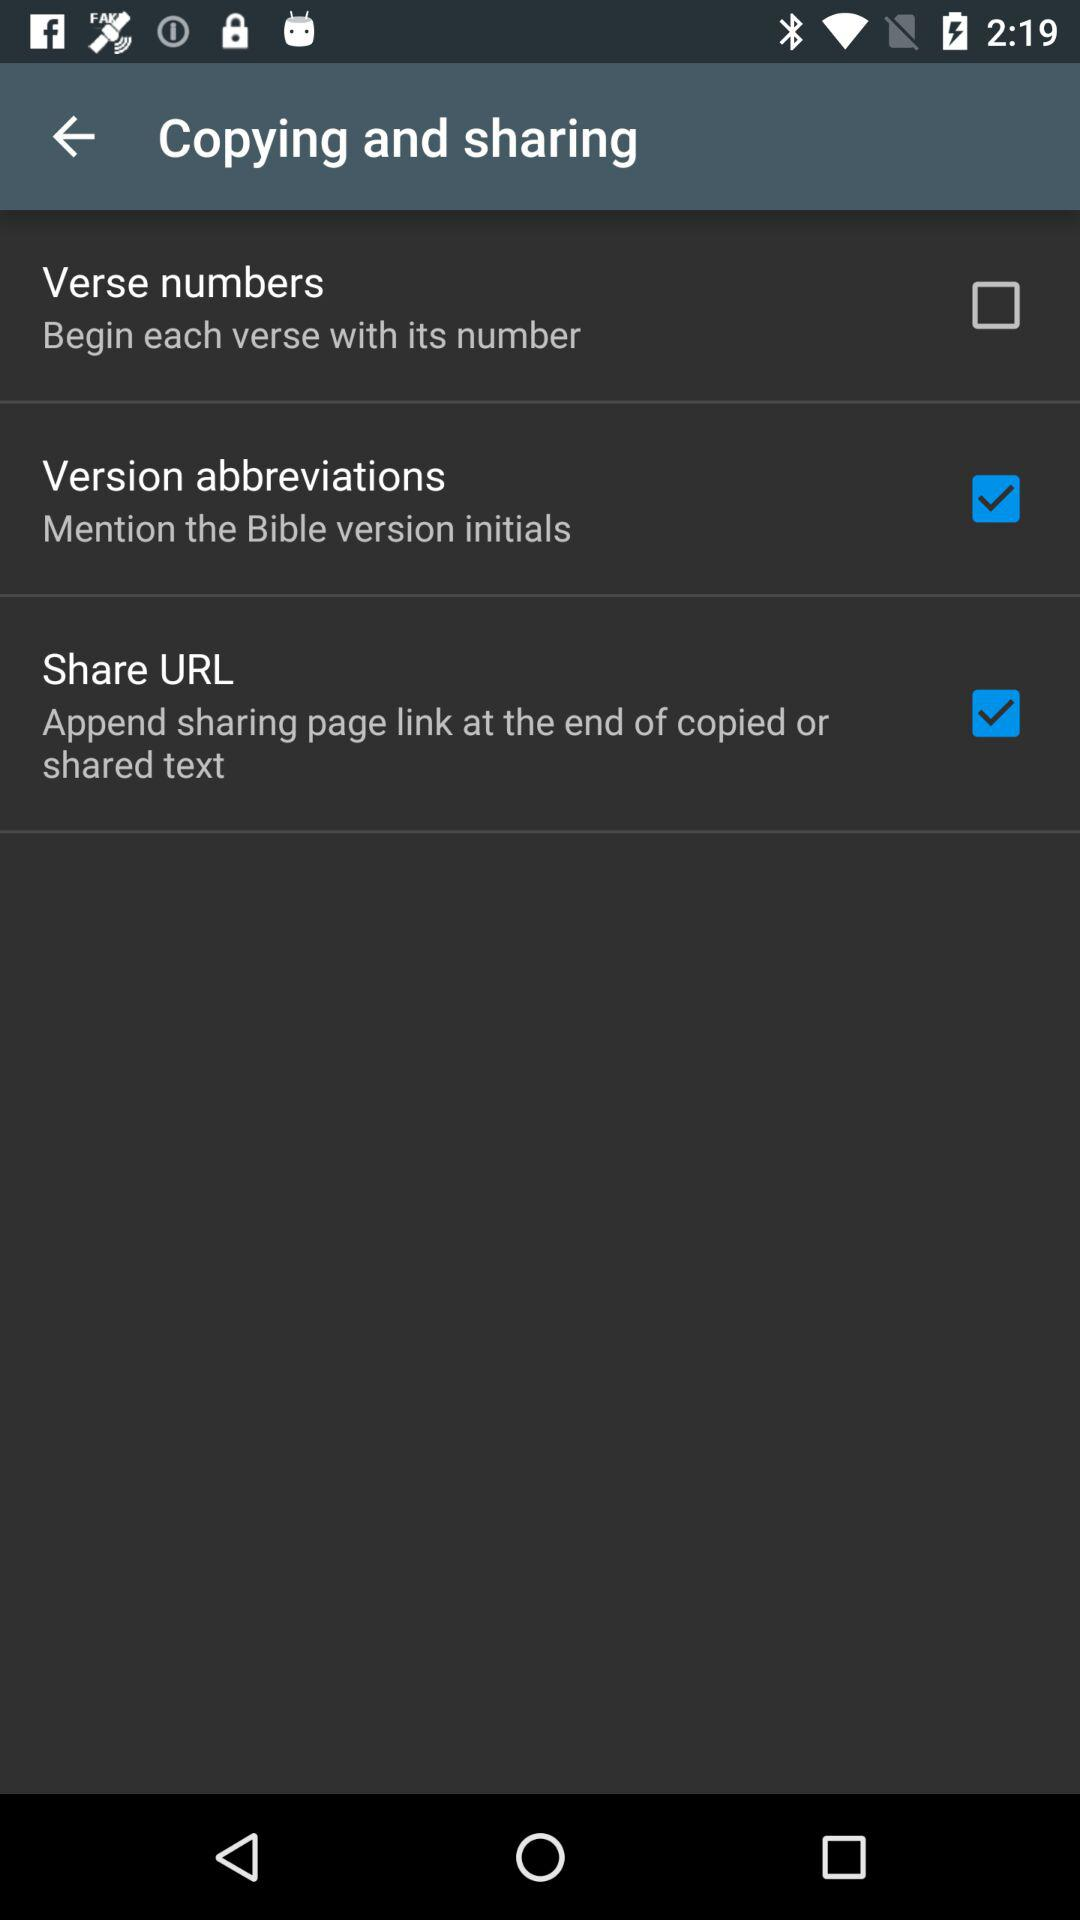What are the selected options in "Copying and sharing"? The selected options are "Version abbreviations" and "Share URL". 